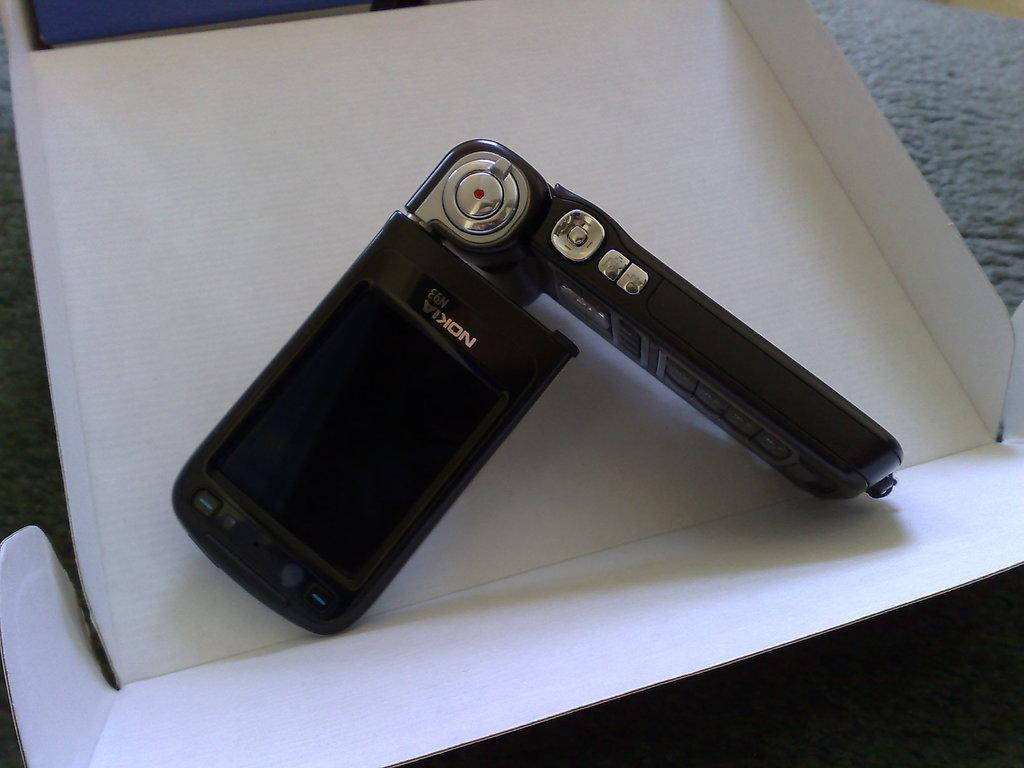Where was the image taken? The image was taken indoors. What can be seen in the background of the image? There is a gray surface in the background of the image. What is the main object in the middle of the image? There is a mobile phone in the middle of the image. On what is the mobile phone placed? The mobile phone is placed on a cardboard box. What type of fairies can be seen flying around the mobile phone in the image? There are no fairies present in the image; it only features a mobile phone placed on a cardboard box. 